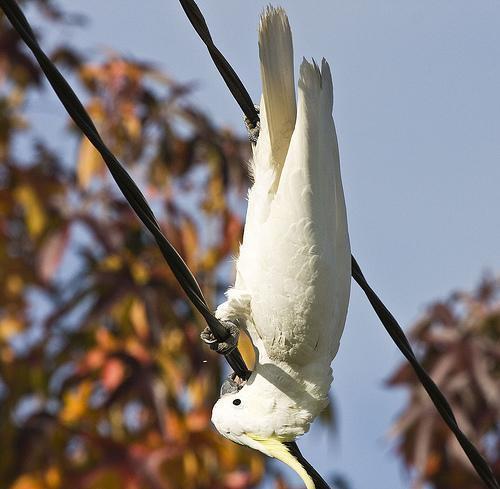How many electrical lines can be seen?
Give a very brief answer. 2. 